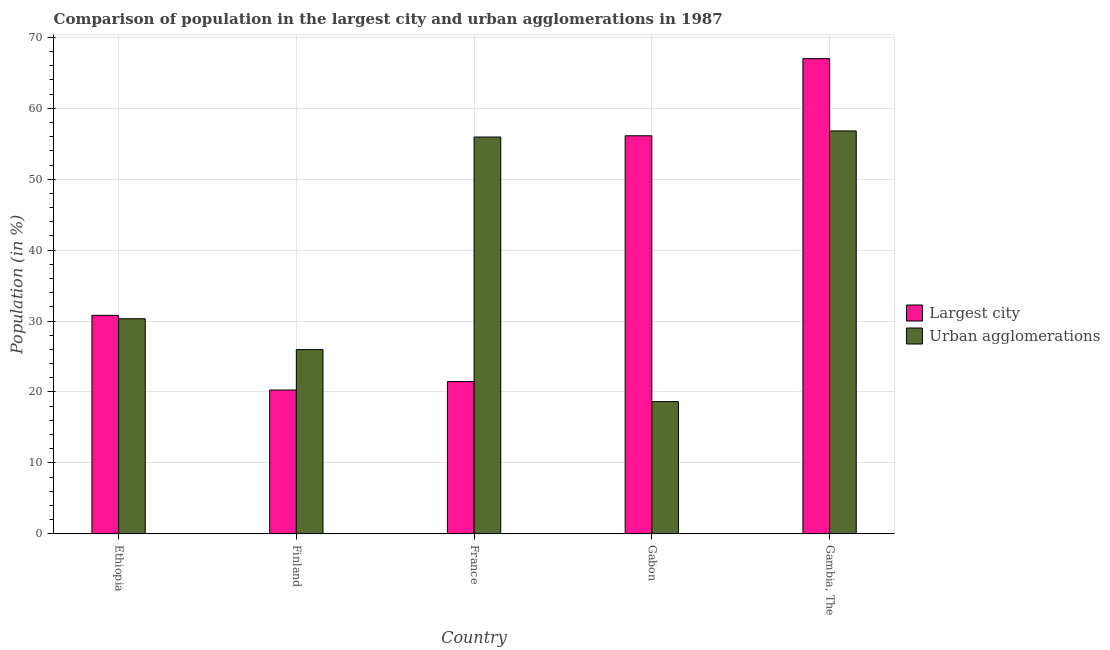How many different coloured bars are there?
Offer a very short reply. 2. Are the number of bars on each tick of the X-axis equal?
Offer a very short reply. Yes. How many bars are there on the 3rd tick from the left?
Offer a terse response. 2. What is the label of the 2nd group of bars from the left?
Your answer should be very brief. Finland. What is the population in urban agglomerations in France?
Offer a very short reply. 55.94. Across all countries, what is the maximum population in the largest city?
Offer a terse response. 67. Across all countries, what is the minimum population in urban agglomerations?
Offer a terse response. 18.65. In which country was the population in the largest city maximum?
Offer a terse response. Gambia, The. In which country was the population in urban agglomerations minimum?
Provide a short and direct response. Gabon. What is the total population in urban agglomerations in the graph?
Provide a succinct answer. 187.7. What is the difference between the population in the largest city in Finland and that in Gambia, The?
Your answer should be very brief. -46.72. What is the difference between the population in the largest city in Gambia, The and the population in urban agglomerations in Ethiopia?
Ensure brevity in your answer.  36.67. What is the average population in the largest city per country?
Your answer should be very brief. 39.14. What is the difference between the population in urban agglomerations and population in the largest city in France?
Ensure brevity in your answer.  34.47. What is the ratio of the population in urban agglomerations in Ethiopia to that in Finland?
Ensure brevity in your answer.  1.17. Is the population in urban agglomerations in Finland less than that in France?
Offer a very short reply. Yes. What is the difference between the highest and the second highest population in the largest city?
Your answer should be compact. 10.87. What is the difference between the highest and the lowest population in urban agglomerations?
Provide a succinct answer. 38.16. What does the 1st bar from the left in France represents?
Ensure brevity in your answer.  Largest city. What does the 2nd bar from the right in Gambia, The represents?
Offer a very short reply. Largest city. How many countries are there in the graph?
Provide a succinct answer. 5. Are the values on the major ticks of Y-axis written in scientific E-notation?
Give a very brief answer. No. How many legend labels are there?
Provide a short and direct response. 2. How are the legend labels stacked?
Keep it short and to the point. Vertical. What is the title of the graph?
Offer a terse response. Comparison of population in the largest city and urban agglomerations in 1987. Does "Secondary education" appear as one of the legend labels in the graph?
Make the answer very short. No. What is the Population (in %) in Largest city in Ethiopia?
Keep it short and to the point. 30.81. What is the Population (in %) in Urban agglomerations in Ethiopia?
Offer a terse response. 30.33. What is the Population (in %) in Largest city in Finland?
Ensure brevity in your answer.  20.28. What is the Population (in %) in Urban agglomerations in Finland?
Offer a terse response. 25.98. What is the Population (in %) in Largest city in France?
Ensure brevity in your answer.  21.47. What is the Population (in %) of Urban agglomerations in France?
Provide a short and direct response. 55.94. What is the Population (in %) in Largest city in Gabon?
Offer a terse response. 56.12. What is the Population (in %) of Urban agglomerations in Gabon?
Offer a very short reply. 18.65. What is the Population (in %) in Largest city in Gambia, The?
Your response must be concise. 67. What is the Population (in %) of Urban agglomerations in Gambia, The?
Your answer should be compact. 56.81. Across all countries, what is the maximum Population (in %) in Largest city?
Give a very brief answer. 67. Across all countries, what is the maximum Population (in %) in Urban agglomerations?
Ensure brevity in your answer.  56.81. Across all countries, what is the minimum Population (in %) in Largest city?
Offer a very short reply. 20.28. Across all countries, what is the minimum Population (in %) of Urban agglomerations?
Your response must be concise. 18.65. What is the total Population (in %) of Largest city in the graph?
Your answer should be compact. 195.68. What is the total Population (in %) of Urban agglomerations in the graph?
Ensure brevity in your answer.  187.7. What is the difference between the Population (in %) of Largest city in Ethiopia and that in Finland?
Provide a succinct answer. 10.53. What is the difference between the Population (in %) in Urban agglomerations in Ethiopia and that in Finland?
Your response must be concise. 4.35. What is the difference between the Population (in %) in Largest city in Ethiopia and that in France?
Make the answer very short. 9.34. What is the difference between the Population (in %) of Urban agglomerations in Ethiopia and that in France?
Offer a very short reply. -25.62. What is the difference between the Population (in %) of Largest city in Ethiopia and that in Gabon?
Ensure brevity in your answer.  -25.32. What is the difference between the Population (in %) of Urban agglomerations in Ethiopia and that in Gabon?
Offer a very short reply. 11.68. What is the difference between the Population (in %) in Largest city in Ethiopia and that in Gambia, The?
Give a very brief answer. -36.19. What is the difference between the Population (in %) in Urban agglomerations in Ethiopia and that in Gambia, The?
Give a very brief answer. -26.48. What is the difference between the Population (in %) in Largest city in Finland and that in France?
Your response must be concise. -1.2. What is the difference between the Population (in %) in Urban agglomerations in Finland and that in France?
Your response must be concise. -29.97. What is the difference between the Population (in %) of Largest city in Finland and that in Gabon?
Provide a succinct answer. -35.85. What is the difference between the Population (in %) of Urban agglomerations in Finland and that in Gabon?
Your answer should be compact. 7.33. What is the difference between the Population (in %) in Largest city in Finland and that in Gambia, The?
Offer a terse response. -46.72. What is the difference between the Population (in %) in Urban agglomerations in Finland and that in Gambia, The?
Offer a very short reply. -30.83. What is the difference between the Population (in %) in Largest city in France and that in Gabon?
Ensure brevity in your answer.  -34.65. What is the difference between the Population (in %) in Urban agglomerations in France and that in Gabon?
Keep it short and to the point. 37.3. What is the difference between the Population (in %) in Largest city in France and that in Gambia, The?
Make the answer very short. -45.52. What is the difference between the Population (in %) of Urban agglomerations in France and that in Gambia, The?
Keep it short and to the point. -0.86. What is the difference between the Population (in %) in Largest city in Gabon and that in Gambia, The?
Your answer should be very brief. -10.87. What is the difference between the Population (in %) in Urban agglomerations in Gabon and that in Gambia, The?
Your response must be concise. -38.16. What is the difference between the Population (in %) in Largest city in Ethiopia and the Population (in %) in Urban agglomerations in Finland?
Offer a terse response. 4.83. What is the difference between the Population (in %) in Largest city in Ethiopia and the Population (in %) in Urban agglomerations in France?
Your response must be concise. -25.14. What is the difference between the Population (in %) of Largest city in Ethiopia and the Population (in %) of Urban agglomerations in Gabon?
Your answer should be compact. 12.16. What is the difference between the Population (in %) of Largest city in Ethiopia and the Population (in %) of Urban agglomerations in Gambia, The?
Give a very brief answer. -26. What is the difference between the Population (in %) of Largest city in Finland and the Population (in %) of Urban agglomerations in France?
Provide a short and direct response. -35.67. What is the difference between the Population (in %) of Largest city in Finland and the Population (in %) of Urban agglomerations in Gabon?
Provide a short and direct response. 1.63. What is the difference between the Population (in %) in Largest city in Finland and the Population (in %) in Urban agglomerations in Gambia, The?
Offer a very short reply. -36.53. What is the difference between the Population (in %) of Largest city in France and the Population (in %) of Urban agglomerations in Gabon?
Keep it short and to the point. 2.83. What is the difference between the Population (in %) of Largest city in France and the Population (in %) of Urban agglomerations in Gambia, The?
Offer a very short reply. -35.33. What is the difference between the Population (in %) of Largest city in Gabon and the Population (in %) of Urban agglomerations in Gambia, The?
Provide a short and direct response. -0.68. What is the average Population (in %) of Largest city per country?
Provide a succinct answer. 39.14. What is the average Population (in %) of Urban agglomerations per country?
Your answer should be compact. 37.54. What is the difference between the Population (in %) in Largest city and Population (in %) in Urban agglomerations in Ethiopia?
Your answer should be very brief. 0.48. What is the difference between the Population (in %) of Largest city and Population (in %) of Urban agglomerations in Finland?
Make the answer very short. -5.7. What is the difference between the Population (in %) in Largest city and Population (in %) in Urban agglomerations in France?
Make the answer very short. -34.47. What is the difference between the Population (in %) in Largest city and Population (in %) in Urban agglomerations in Gabon?
Provide a short and direct response. 37.48. What is the difference between the Population (in %) of Largest city and Population (in %) of Urban agglomerations in Gambia, The?
Make the answer very short. 10.19. What is the ratio of the Population (in %) in Largest city in Ethiopia to that in Finland?
Your answer should be compact. 1.52. What is the ratio of the Population (in %) of Urban agglomerations in Ethiopia to that in Finland?
Give a very brief answer. 1.17. What is the ratio of the Population (in %) of Largest city in Ethiopia to that in France?
Provide a short and direct response. 1.43. What is the ratio of the Population (in %) of Urban agglomerations in Ethiopia to that in France?
Give a very brief answer. 0.54. What is the ratio of the Population (in %) in Largest city in Ethiopia to that in Gabon?
Your answer should be very brief. 0.55. What is the ratio of the Population (in %) of Urban agglomerations in Ethiopia to that in Gabon?
Your answer should be very brief. 1.63. What is the ratio of the Population (in %) of Largest city in Ethiopia to that in Gambia, The?
Provide a succinct answer. 0.46. What is the ratio of the Population (in %) of Urban agglomerations in Ethiopia to that in Gambia, The?
Offer a terse response. 0.53. What is the ratio of the Population (in %) of Largest city in Finland to that in France?
Keep it short and to the point. 0.94. What is the ratio of the Population (in %) of Urban agglomerations in Finland to that in France?
Your response must be concise. 0.46. What is the ratio of the Population (in %) of Largest city in Finland to that in Gabon?
Keep it short and to the point. 0.36. What is the ratio of the Population (in %) in Urban agglomerations in Finland to that in Gabon?
Your answer should be compact. 1.39. What is the ratio of the Population (in %) of Largest city in Finland to that in Gambia, The?
Your answer should be compact. 0.3. What is the ratio of the Population (in %) of Urban agglomerations in Finland to that in Gambia, The?
Your response must be concise. 0.46. What is the ratio of the Population (in %) of Largest city in France to that in Gabon?
Ensure brevity in your answer.  0.38. What is the ratio of the Population (in %) of Urban agglomerations in France to that in Gabon?
Make the answer very short. 3. What is the ratio of the Population (in %) in Largest city in France to that in Gambia, The?
Your answer should be very brief. 0.32. What is the ratio of the Population (in %) in Largest city in Gabon to that in Gambia, The?
Keep it short and to the point. 0.84. What is the ratio of the Population (in %) in Urban agglomerations in Gabon to that in Gambia, The?
Your answer should be very brief. 0.33. What is the difference between the highest and the second highest Population (in %) of Largest city?
Your answer should be very brief. 10.87. What is the difference between the highest and the second highest Population (in %) of Urban agglomerations?
Make the answer very short. 0.86. What is the difference between the highest and the lowest Population (in %) of Largest city?
Your answer should be very brief. 46.72. What is the difference between the highest and the lowest Population (in %) in Urban agglomerations?
Ensure brevity in your answer.  38.16. 